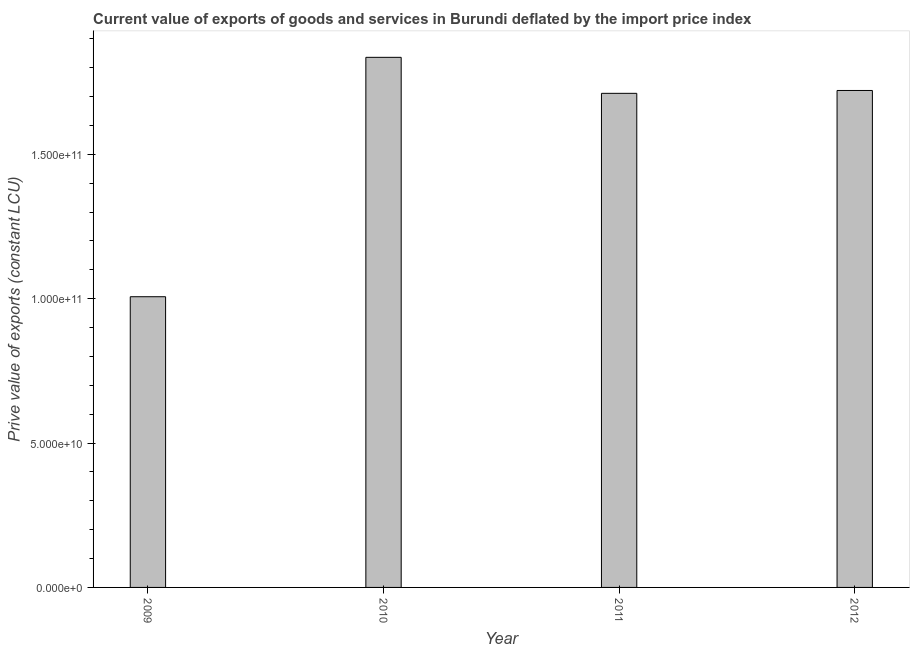Does the graph contain any zero values?
Offer a very short reply. No. Does the graph contain grids?
Your answer should be compact. No. What is the title of the graph?
Offer a terse response. Current value of exports of goods and services in Burundi deflated by the import price index. What is the label or title of the Y-axis?
Your answer should be very brief. Prive value of exports (constant LCU). What is the price value of exports in 2010?
Your answer should be very brief. 1.84e+11. Across all years, what is the maximum price value of exports?
Offer a very short reply. 1.84e+11. Across all years, what is the minimum price value of exports?
Your answer should be very brief. 1.01e+11. In which year was the price value of exports minimum?
Keep it short and to the point. 2009. What is the sum of the price value of exports?
Provide a succinct answer. 6.28e+11. What is the difference between the price value of exports in 2011 and 2012?
Offer a very short reply. -9.90e+08. What is the average price value of exports per year?
Provide a short and direct response. 1.57e+11. What is the median price value of exports?
Provide a short and direct response. 1.72e+11. In how many years, is the price value of exports greater than 160000000000 LCU?
Provide a short and direct response. 3. Do a majority of the years between 2009 and 2011 (inclusive) have price value of exports greater than 150000000000 LCU?
Make the answer very short. Yes. What is the ratio of the price value of exports in 2010 to that in 2012?
Your answer should be compact. 1.07. Is the price value of exports in 2010 less than that in 2012?
Ensure brevity in your answer.  No. Is the difference between the price value of exports in 2009 and 2011 greater than the difference between any two years?
Offer a very short reply. No. What is the difference between the highest and the second highest price value of exports?
Your response must be concise. 1.15e+1. What is the difference between the highest and the lowest price value of exports?
Ensure brevity in your answer.  8.29e+1. In how many years, is the price value of exports greater than the average price value of exports taken over all years?
Give a very brief answer. 3. What is the difference between two consecutive major ticks on the Y-axis?
Ensure brevity in your answer.  5.00e+1. Are the values on the major ticks of Y-axis written in scientific E-notation?
Provide a succinct answer. Yes. What is the Prive value of exports (constant LCU) of 2009?
Your answer should be compact. 1.01e+11. What is the Prive value of exports (constant LCU) of 2010?
Offer a very short reply. 1.84e+11. What is the Prive value of exports (constant LCU) in 2011?
Give a very brief answer. 1.71e+11. What is the Prive value of exports (constant LCU) in 2012?
Keep it short and to the point. 1.72e+11. What is the difference between the Prive value of exports (constant LCU) in 2009 and 2010?
Your answer should be compact. -8.29e+1. What is the difference between the Prive value of exports (constant LCU) in 2009 and 2011?
Ensure brevity in your answer.  -7.04e+1. What is the difference between the Prive value of exports (constant LCU) in 2009 and 2012?
Your response must be concise. -7.14e+1. What is the difference between the Prive value of exports (constant LCU) in 2010 and 2011?
Your answer should be very brief. 1.25e+1. What is the difference between the Prive value of exports (constant LCU) in 2010 and 2012?
Keep it short and to the point. 1.15e+1. What is the difference between the Prive value of exports (constant LCU) in 2011 and 2012?
Your answer should be very brief. -9.90e+08. What is the ratio of the Prive value of exports (constant LCU) in 2009 to that in 2010?
Ensure brevity in your answer.  0.55. What is the ratio of the Prive value of exports (constant LCU) in 2009 to that in 2011?
Make the answer very short. 0.59. What is the ratio of the Prive value of exports (constant LCU) in 2009 to that in 2012?
Your response must be concise. 0.58. What is the ratio of the Prive value of exports (constant LCU) in 2010 to that in 2011?
Keep it short and to the point. 1.07. What is the ratio of the Prive value of exports (constant LCU) in 2010 to that in 2012?
Keep it short and to the point. 1.07. What is the ratio of the Prive value of exports (constant LCU) in 2011 to that in 2012?
Provide a short and direct response. 0.99. 